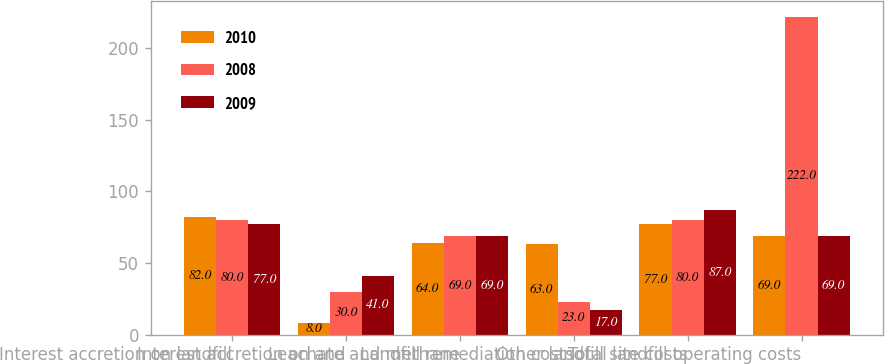<chart> <loc_0><loc_0><loc_500><loc_500><stacked_bar_chart><ecel><fcel>Interest accretion on landfill<fcel>Interest accretion on and<fcel>Leachate and methane<fcel>Landfill remediation costs<fcel>Other landfill site costs<fcel>Total landfill operating costs<nl><fcel>2010<fcel>82<fcel>8<fcel>64<fcel>63<fcel>77<fcel>69<nl><fcel>2008<fcel>80<fcel>30<fcel>69<fcel>23<fcel>80<fcel>222<nl><fcel>2009<fcel>77<fcel>41<fcel>69<fcel>17<fcel>87<fcel>69<nl></chart> 